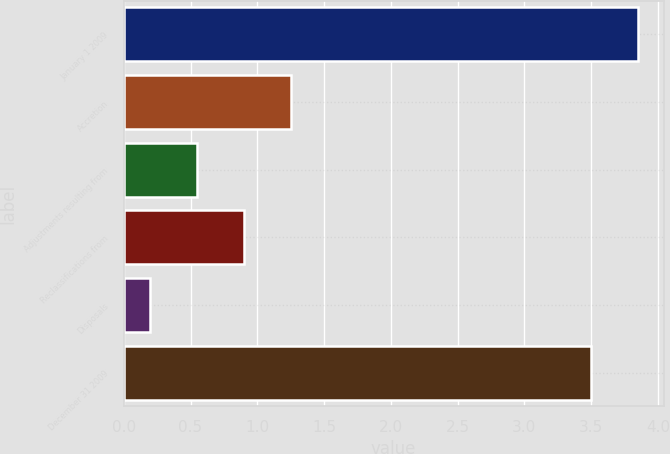<chart> <loc_0><loc_0><loc_500><loc_500><bar_chart><fcel>January 1 2009<fcel>Accretion<fcel>Adjustments resulting from<fcel>Reclassifications from<fcel>Disposals<fcel>December 31 2009<nl><fcel>3.85<fcel>1.25<fcel>0.55<fcel>0.9<fcel>0.2<fcel>3.5<nl></chart> 